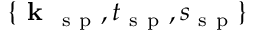Convert formula to latex. <formula><loc_0><loc_0><loc_500><loc_500>\{ k _ { s p } , t _ { s p } , s _ { s p } \}</formula> 